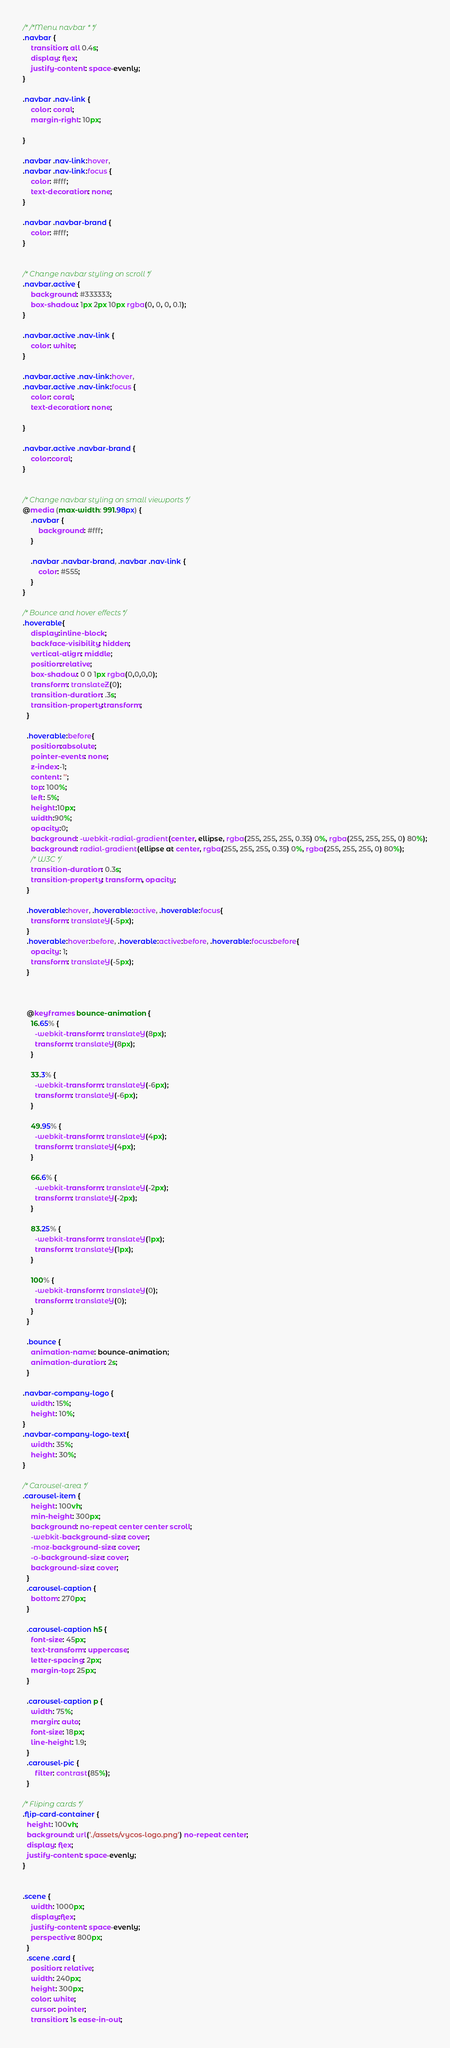Convert code to text. <code><loc_0><loc_0><loc_500><loc_500><_CSS_>/* /*Menu navbar * */
.navbar {
    transition: all 0.4s;
    display: flex;
    justify-content: space-evenly;
}

.navbar .nav-link {
    color: coral;
    margin-right: 10px;
   
}

.navbar .nav-link:hover,
.navbar .nav-link:focus {
    color: #fff;
    text-decoration: none;
}

.navbar .navbar-brand {
    color: #fff;
}


/* Change navbar styling on scroll */
.navbar.active {
    background: #333333;
    box-shadow: 1px 2px 10px rgba(0, 0, 0, 0.1);
}

.navbar.active .nav-link {
    color: white;
}

.navbar.active .nav-link:hover,
.navbar.active .nav-link:focus {
    color: coral;
    text-decoration: none;
    
}

.navbar.active .navbar-brand {
    color:coral;
}


/* Change navbar styling on small viewports */
@media (max-width: 991.98px) {
    .navbar {
        background: #fff;
    }

    .navbar .navbar-brand, .navbar .nav-link {
        color: #555;
    }
}

/* Bounce and hover effects */
.hoverable{
    display:inline-block;
    backface-visibility: hidden;
    vertical-align: middle;
    position:relative;
    box-shadow: 0 0 1px rgba(0,0,0,0);
    transform: translateZ(0);
    transition-duration: .3s;
    transition-property:transform;
  }
  
  .hoverable:before{
    position:absolute;
    pointer-events: none;
    z-index:-1;
    content: '';
    top: 100%;
    left: 5%;
    height:10px;
    width:90%;
    opacity:0;
    background: -webkit-radial-gradient(center, ellipse, rgba(255, 255, 255, 0.35) 0%, rgba(255, 255, 255, 0) 80%);
    background: radial-gradient(ellipse at center, rgba(255, 255, 255, 0.35) 0%, rgba(255, 255, 255, 0) 80%);
    /* W3C */
    transition-duration: 0.3s;
    transition-property: transform, opacity;
  }
  
  .hoverable:hover, .hoverable:active, .hoverable:focus{
    transform: translateY(-5px);
  }
  .hoverable:hover:before, .hoverable:active:before, .hoverable:focus:before{
    opacity: 1;
    transform: translateY(-5px);
  }
  
  
  
  @keyframes bounce-animation {
    16.65% {
      -webkit-transform: translateY(8px);
      transform: translateY(8px);
    }
  
    33.3% {
      -webkit-transform: translateY(-6px);
      transform: translateY(-6px);
    }
  
    49.95% {
      -webkit-transform: translateY(4px);
      transform: translateY(4px);
    }
  
    66.6% {
      -webkit-transform: translateY(-2px);
      transform: translateY(-2px);
    }
  
    83.25% {
      -webkit-transform: translateY(1px);
      transform: translateY(1px);
    }
  
    100% {
      -webkit-transform: translateY(0);
      transform: translateY(0);
    }
  }
  
  .bounce {
    animation-name: bounce-animation;
    animation-duration: 2s;
  }

.navbar-company-logo {
    width: 15%;
    height: 10%;
}
.navbar-company-logo-text{
    width: 35%;
    height: 30%;
}

/* Carousel-area */
.carousel-item {
    height: 100vh;
    min-height: 300px;
    background: no-repeat center center scroll;
    -webkit-background-size: cover;
    -moz-background-size: cover;
    -o-background-size: cover;
    background-size: cover;
  }
  .carousel-caption {
    bottom: 270px;
  }
  
  .carousel-caption h5 {
    font-size: 45px;
    text-transform: uppercase;
    letter-spacing: 2px;
    margin-top: 25px;
  }
  
  .carousel-caption p {
    width: 75%;
    margin: auto;
    font-size: 18px;
    line-height: 1.9;
  }
  .carousel-pic {
      filter: contrast(85%);
  }

/* Fliping cards */
.flip-card-container {
  height: 100vh;
  background: url('./assets/vycos-logo.png') no-repeat center;
  display: flex;
  justify-content: space-evenly;
}


.scene {
    width: 1000px;
    display:flex;
    justify-content: space-evenly;
    perspective: 800px;
  }
  .scene .card {
    position: relative;
    width: 240px;
    height: 300px;
    color: white;
    cursor: pointer;
    transition: 1s ease-in-out;</code> 